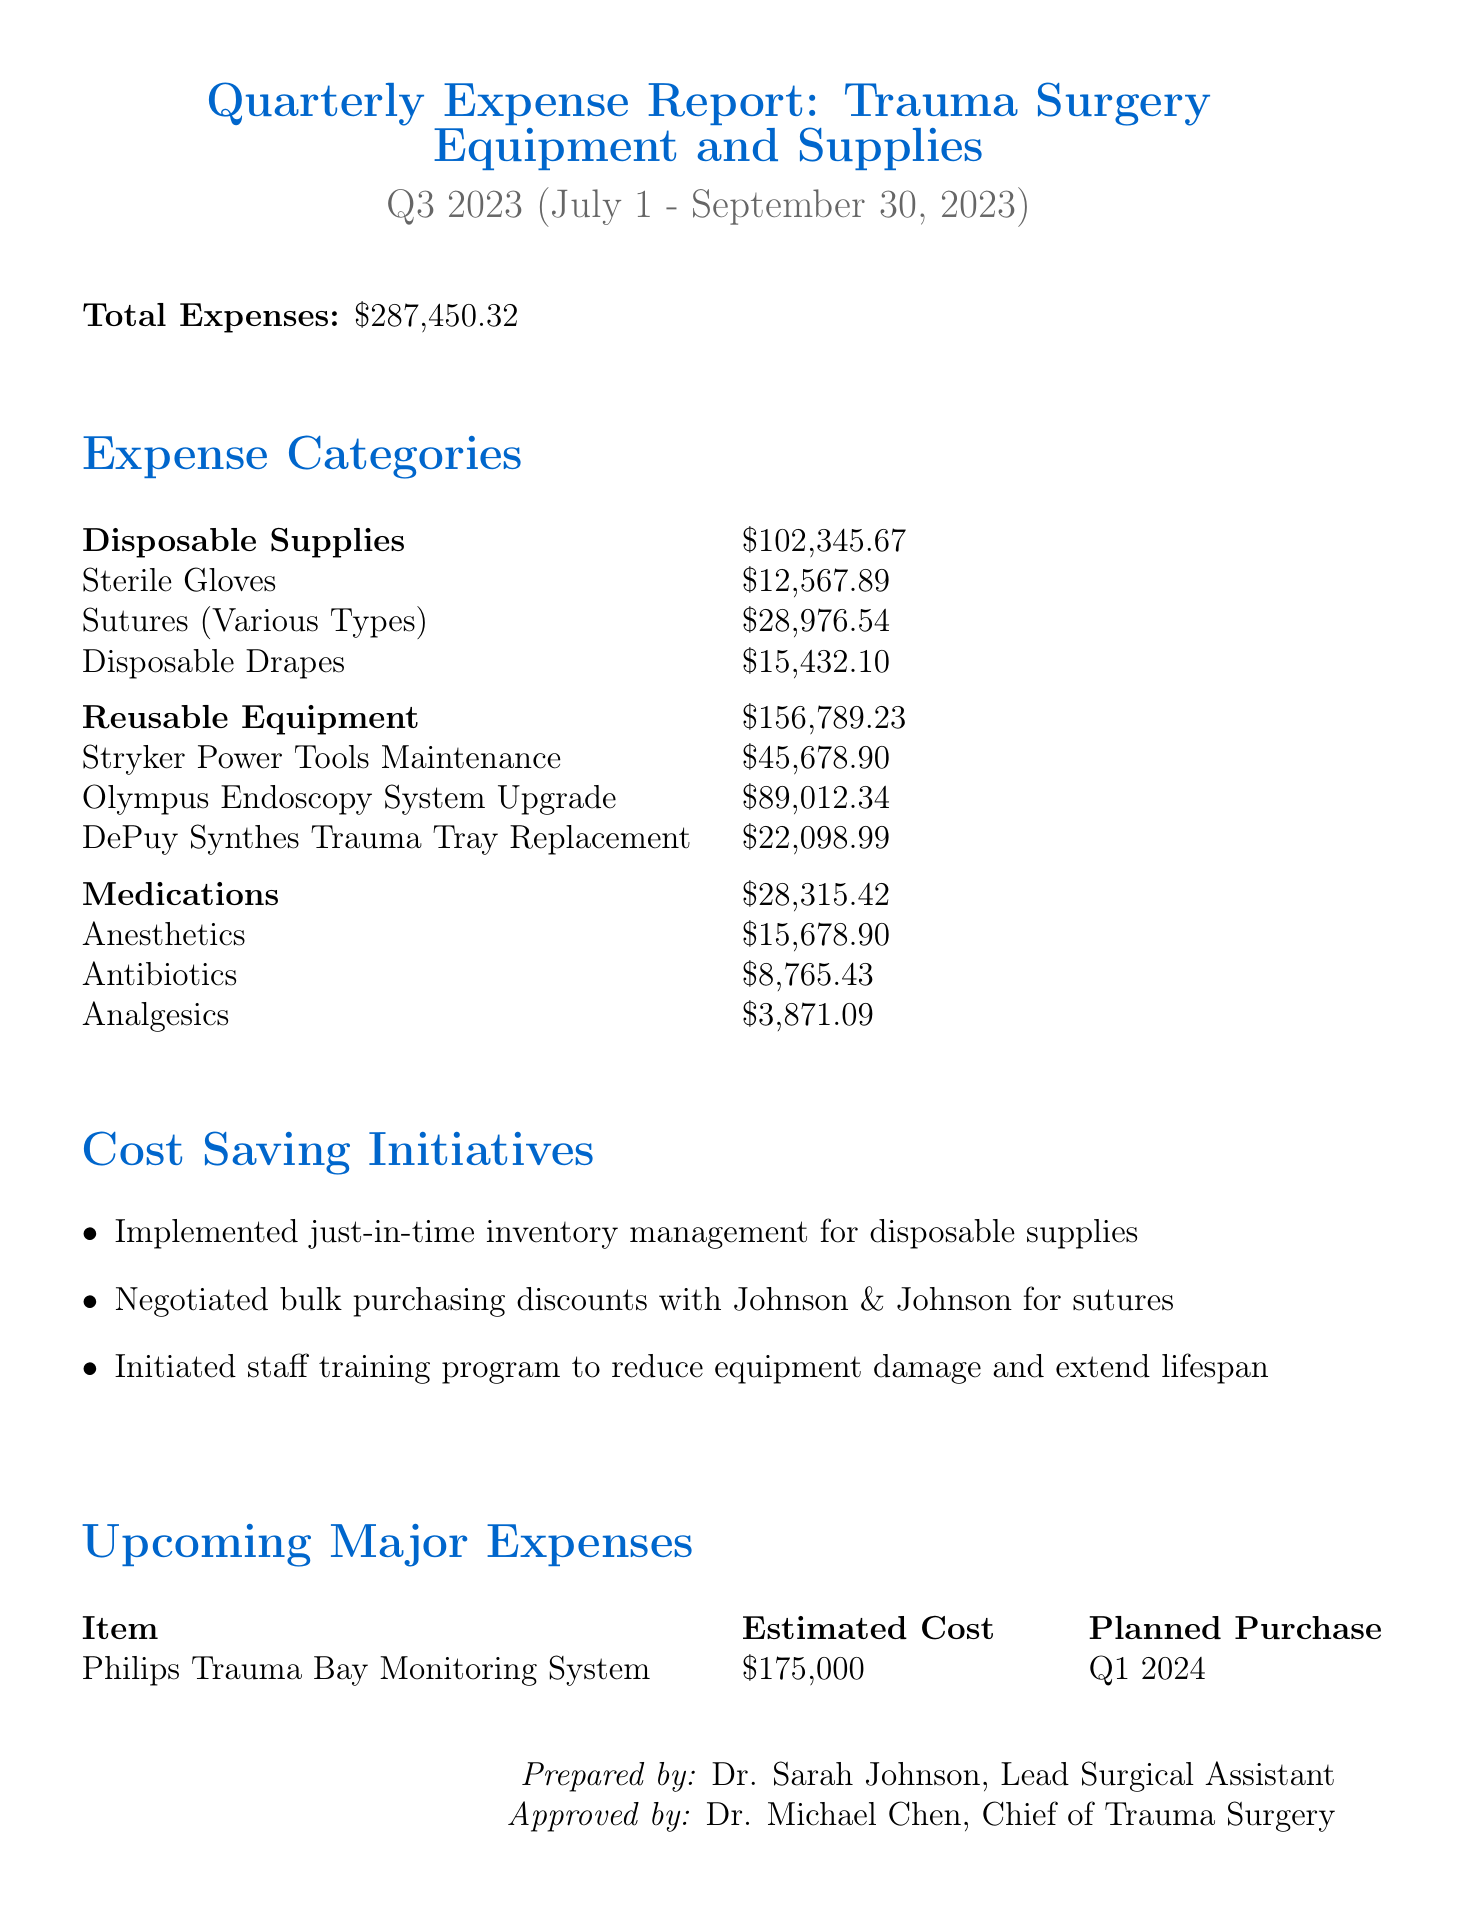What is the total expense for Q3 2023? The total expenses reported for Q3 2023 is clearly stated in the document.
Answer: $287,450.32 How much was spent on Disposable Supplies? The report explicitly lists the total for Disposable Supplies as part of the expense categories.
Answer: $102,345.67 Who prepared the report? The document identifies the person responsible for preparing the report at the end.
Answer: Dr. Sarah Johnson, Lead Surgical Assistant What is the estimated cost of the Philips Trauma Bay Monitoring System? The upcoming major expenses section provides the estimated cost specified for this item.
Answer: $175,000 Which category had the highest expenditure? By comparing the totals in the expense categories, we can determine which one has the highest amount.
Answer: Reusable Equipment How many cost-saving initiatives are mentioned? The document lists the specific initiatives aimed at reducing costs, and their count can be easily counted.
Answer: 3 What type of equipment is the Olympus Endoscopy System classified as? The detail regarding the Olympus Endoscopy System can be found in the expense categories section.
Answer: Reusable Equipment When is the planned purchase date for the Philips Trauma Bay Monitoring System? The planned purchase date is noted under the upcoming major expenses section.
Answer: Q1 2024 